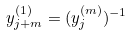<formula> <loc_0><loc_0><loc_500><loc_500>y _ { j + m } ^ { ( 1 ) } = ( y _ { j } ^ { ( m ) } ) ^ { - 1 }</formula> 